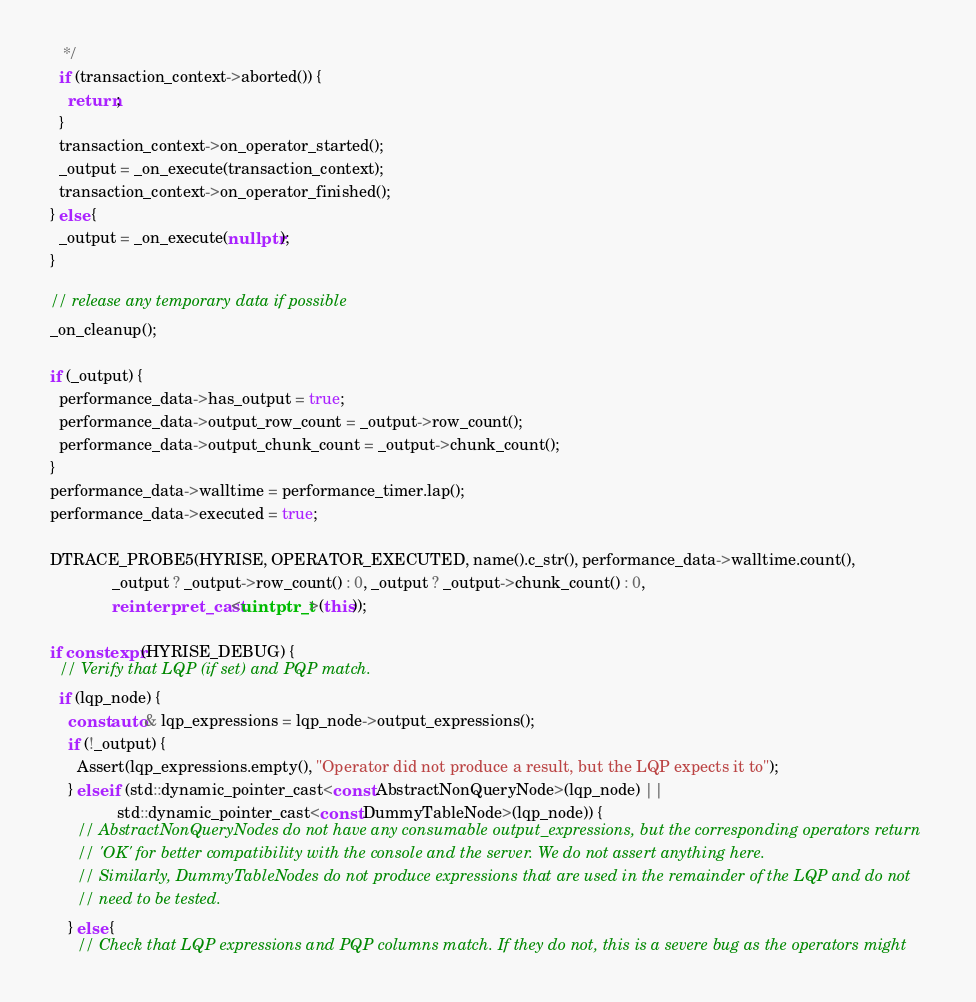Convert code to text. <code><loc_0><loc_0><loc_500><loc_500><_C++_>     */
    if (transaction_context->aborted()) {
      return;
    }
    transaction_context->on_operator_started();
    _output = _on_execute(transaction_context);
    transaction_context->on_operator_finished();
  } else {
    _output = _on_execute(nullptr);
  }

  // release any temporary data if possible
  _on_cleanup();

  if (_output) {
    performance_data->has_output = true;
    performance_data->output_row_count = _output->row_count();
    performance_data->output_chunk_count = _output->chunk_count();
  }
  performance_data->walltime = performance_timer.lap();
  performance_data->executed = true;

  DTRACE_PROBE5(HYRISE, OPERATOR_EXECUTED, name().c_str(), performance_data->walltime.count(),
                _output ? _output->row_count() : 0, _output ? _output->chunk_count() : 0,
                reinterpret_cast<uintptr_t>(this));

  if constexpr (HYRISE_DEBUG) {
    // Verify that LQP (if set) and PQP match.
    if (lqp_node) {
      const auto& lqp_expressions = lqp_node->output_expressions();
      if (!_output) {
        Assert(lqp_expressions.empty(), "Operator did not produce a result, but the LQP expects it to");
      } else if (std::dynamic_pointer_cast<const AbstractNonQueryNode>(lqp_node) ||
                 std::dynamic_pointer_cast<const DummyTableNode>(lqp_node)) {
        // AbstractNonQueryNodes do not have any consumable output_expressions, but the corresponding operators return
        // 'OK' for better compatibility with the console and the server. We do not assert anything here.
        // Similarly, DummyTableNodes do not produce expressions that are used in the remainder of the LQP and do not
        // need to be tested.
      } else {
        // Check that LQP expressions and PQP columns match. If they do not, this is a severe bug as the operators might</code> 